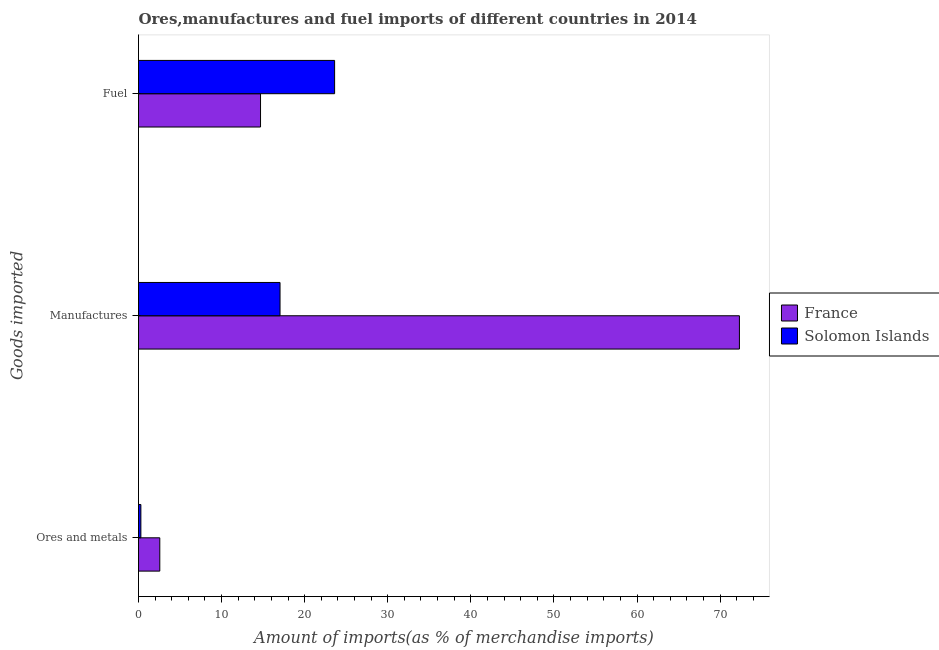How many groups of bars are there?
Offer a terse response. 3. Are the number of bars on each tick of the Y-axis equal?
Offer a terse response. Yes. How many bars are there on the 2nd tick from the top?
Make the answer very short. 2. What is the label of the 3rd group of bars from the top?
Offer a very short reply. Ores and metals. What is the percentage of ores and metals imports in France?
Keep it short and to the point. 2.56. Across all countries, what is the maximum percentage of fuel imports?
Offer a very short reply. 23.6. Across all countries, what is the minimum percentage of ores and metals imports?
Give a very brief answer. 0.29. In which country was the percentage of fuel imports maximum?
Offer a terse response. Solomon Islands. In which country was the percentage of manufactures imports minimum?
Provide a succinct answer. Solomon Islands. What is the total percentage of manufactures imports in the graph?
Provide a succinct answer. 89.36. What is the difference between the percentage of ores and metals imports in France and that in Solomon Islands?
Keep it short and to the point. 2.28. What is the difference between the percentage of fuel imports in Solomon Islands and the percentage of manufactures imports in France?
Offer a very short reply. -48.72. What is the average percentage of manufactures imports per country?
Give a very brief answer. 44.68. What is the difference between the percentage of manufactures imports and percentage of ores and metals imports in Solomon Islands?
Offer a very short reply. 16.75. In how many countries, is the percentage of fuel imports greater than 36 %?
Offer a terse response. 0. What is the ratio of the percentage of ores and metals imports in France to that in Solomon Islands?
Your answer should be compact. 8.97. Is the difference between the percentage of manufactures imports in Solomon Islands and France greater than the difference between the percentage of ores and metals imports in Solomon Islands and France?
Your answer should be compact. No. What is the difference between the highest and the second highest percentage of manufactures imports?
Give a very brief answer. 55.29. What is the difference between the highest and the lowest percentage of ores and metals imports?
Your response must be concise. 2.28. What does the 1st bar from the top in Fuel represents?
Provide a succinct answer. Solomon Islands. What does the 1st bar from the bottom in Ores and metals represents?
Make the answer very short. France. How many countries are there in the graph?
Your answer should be compact. 2. Are the values on the major ticks of X-axis written in scientific E-notation?
Ensure brevity in your answer.  No. Does the graph contain any zero values?
Ensure brevity in your answer.  No. Does the graph contain grids?
Ensure brevity in your answer.  No. How many legend labels are there?
Your response must be concise. 2. How are the legend labels stacked?
Make the answer very short. Vertical. What is the title of the graph?
Provide a short and direct response. Ores,manufactures and fuel imports of different countries in 2014. Does "Jamaica" appear as one of the legend labels in the graph?
Your response must be concise. No. What is the label or title of the X-axis?
Offer a very short reply. Amount of imports(as % of merchandise imports). What is the label or title of the Y-axis?
Offer a very short reply. Goods imported. What is the Amount of imports(as % of merchandise imports) of France in Ores and metals?
Ensure brevity in your answer.  2.56. What is the Amount of imports(as % of merchandise imports) of Solomon Islands in Ores and metals?
Your answer should be compact. 0.29. What is the Amount of imports(as % of merchandise imports) of France in Manufactures?
Make the answer very short. 72.33. What is the Amount of imports(as % of merchandise imports) in Solomon Islands in Manufactures?
Give a very brief answer. 17.03. What is the Amount of imports(as % of merchandise imports) of France in Fuel?
Keep it short and to the point. 14.69. What is the Amount of imports(as % of merchandise imports) of Solomon Islands in Fuel?
Make the answer very short. 23.6. Across all Goods imported, what is the maximum Amount of imports(as % of merchandise imports) in France?
Provide a short and direct response. 72.33. Across all Goods imported, what is the maximum Amount of imports(as % of merchandise imports) in Solomon Islands?
Your answer should be compact. 23.6. Across all Goods imported, what is the minimum Amount of imports(as % of merchandise imports) in France?
Give a very brief answer. 2.56. Across all Goods imported, what is the minimum Amount of imports(as % of merchandise imports) of Solomon Islands?
Offer a very short reply. 0.29. What is the total Amount of imports(as % of merchandise imports) of France in the graph?
Offer a very short reply. 89.58. What is the total Amount of imports(as % of merchandise imports) of Solomon Islands in the graph?
Provide a short and direct response. 40.92. What is the difference between the Amount of imports(as % of merchandise imports) of France in Ores and metals and that in Manufactures?
Offer a terse response. -69.77. What is the difference between the Amount of imports(as % of merchandise imports) of Solomon Islands in Ores and metals and that in Manufactures?
Ensure brevity in your answer.  -16.75. What is the difference between the Amount of imports(as % of merchandise imports) in France in Ores and metals and that in Fuel?
Your response must be concise. -12.12. What is the difference between the Amount of imports(as % of merchandise imports) of Solomon Islands in Ores and metals and that in Fuel?
Provide a succinct answer. -23.32. What is the difference between the Amount of imports(as % of merchandise imports) of France in Manufactures and that in Fuel?
Keep it short and to the point. 57.64. What is the difference between the Amount of imports(as % of merchandise imports) in Solomon Islands in Manufactures and that in Fuel?
Make the answer very short. -6.57. What is the difference between the Amount of imports(as % of merchandise imports) in France in Ores and metals and the Amount of imports(as % of merchandise imports) in Solomon Islands in Manufactures?
Offer a terse response. -14.47. What is the difference between the Amount of imports(as % of merchandise imports) of France in Ores and metals and the Amount of imports(as % of merchandise imports) of Solomon Islands in Fuel?
Your answer should be compact. -21.04. What is the difference between the Amount of imports(as % of merchandise imports) in France in Manufactures and the Amount of imports(as % of merchandise imports) in Solomon Islands in Fuel?
Your answer should be very brief. 48.72. What is the average Amount of imports(as % of merchandise imports) in France per Goods imported?
Offer a terse response. 29.86. What is the average Amount of imports(as % of merchandise imports) of Solomon Islands per Goods imported?
Give a very brief answer. 13.64. What is the difference between the Amount of imports(as % of merchandise imports) in France and Amount of imports(as % of merchandise imports) in Solomon Islands in Ores and metals?
Keep it short and to the point. 2.28. What is the difference between the Amount of imports(as % of merchandise imports) in France and Amount of imports(as % of merchandise imports) in Solomon Islands in Manufactures?
Give a very brief answer. 55.29. What is the difference between the Amount of imports(as % of merchandise imports) of France and Amount of imports(as % of merchandise imports) of Solomon Islands in Fuel?
Offer a very short reply. -8.92. What is the ratio of the Amount of imports(as % of merchandise imports) of France in Ores and metals to that in Manufactures?
Keep it short and to the point. 0.04. What is the ratio of the Amount of imports(as % of merchandise imports) in Solomon Islands in Ores and metals to that in Manufactures?
Keep it short and to the point. 0.02. What is the ratio of the Amount of imports(as % of merchandise imports) of France in Ores and metals to that in Fuel?
Provide a short and direct response. 0.17. What is the ratio of the Amount of imports(as % of merchandise imports) of Solomon Islands in Ores and metals to that in Fuel?
Offer a very short reply. 0.01. What is the ratio of the Amount of imports(as % of merchandise imports) in France in Manufactures to that in Fuel?
Your answer should be compact. 4.92. What is the ratio of the Amount of imports(as % of merchandise imports) of Solomon Islands in Manufactures to that in Fuel?
Your answer should be compact. 0.72. What is the difference between the highest and the second highest Amount of imports(as % of merchandise imports) of France?
Provide a short and direct response. 57.64. What is the difference between the highest and the second highest Amount of imports(as % of merchandise imports) of Solomon Islands?
Offer a terse response. 6.57. What is the difference between the highest and the lowest Amount of imports(as % of merchandise imports) of France?
Provide a short and direct response. 69.77. What is the difference between the highest and the lowest Amount of imports(as % of merchandise imports) of Solomon Islands?
Give a very brief answer. 23.32. 